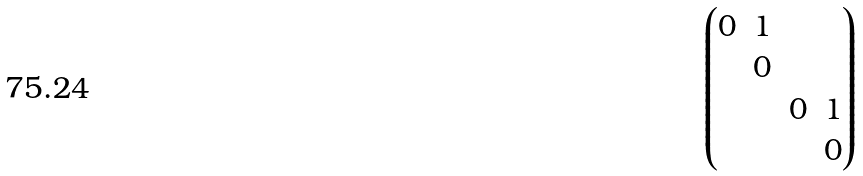<formula> <loc_0><loc_0><loc_500><loc_500>\begin{pmatrix} 0 & 1 & & \\ & 0 & & \\ & & 0 & 1 \\ & & & 0 \end{pmatrix}</formula> 